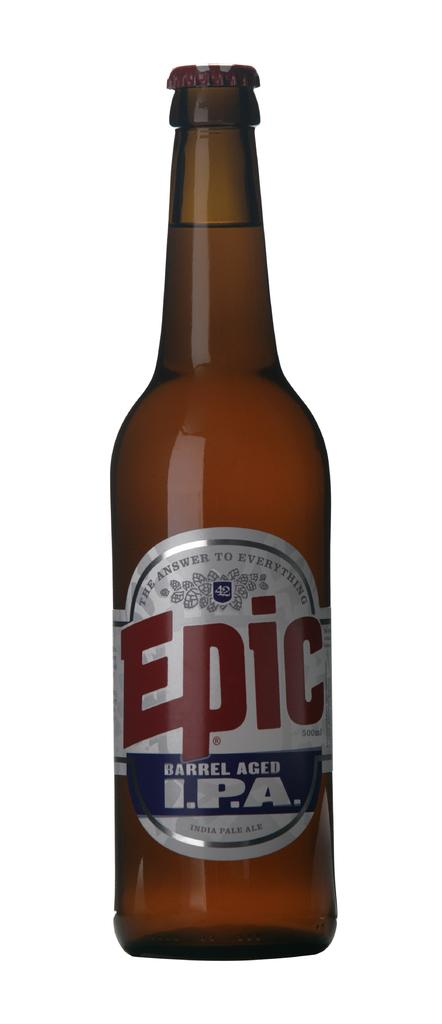<image>
Relay a brief, clear account of the picture shown. A brown bottle has Epic in red letters on the label. 